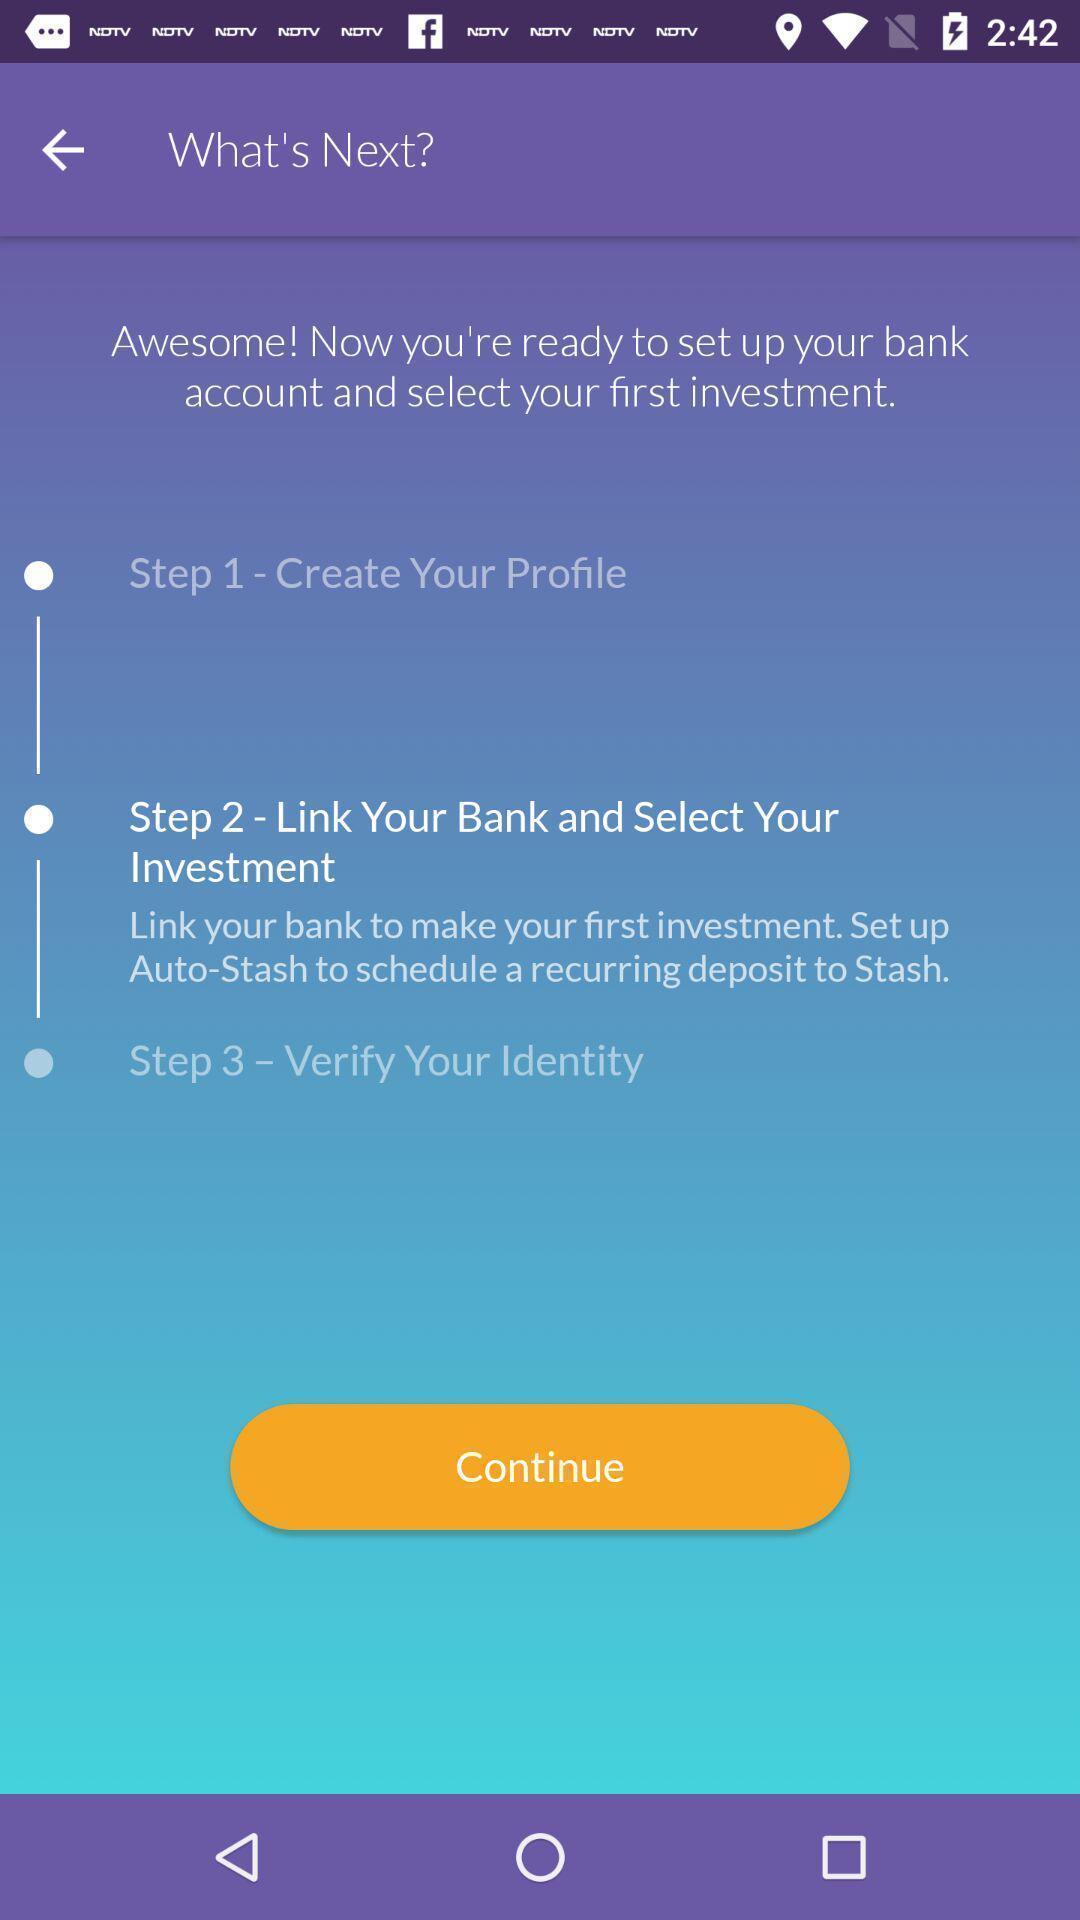Explain what's happening in this screen capture. Steps to set up a bank account. 